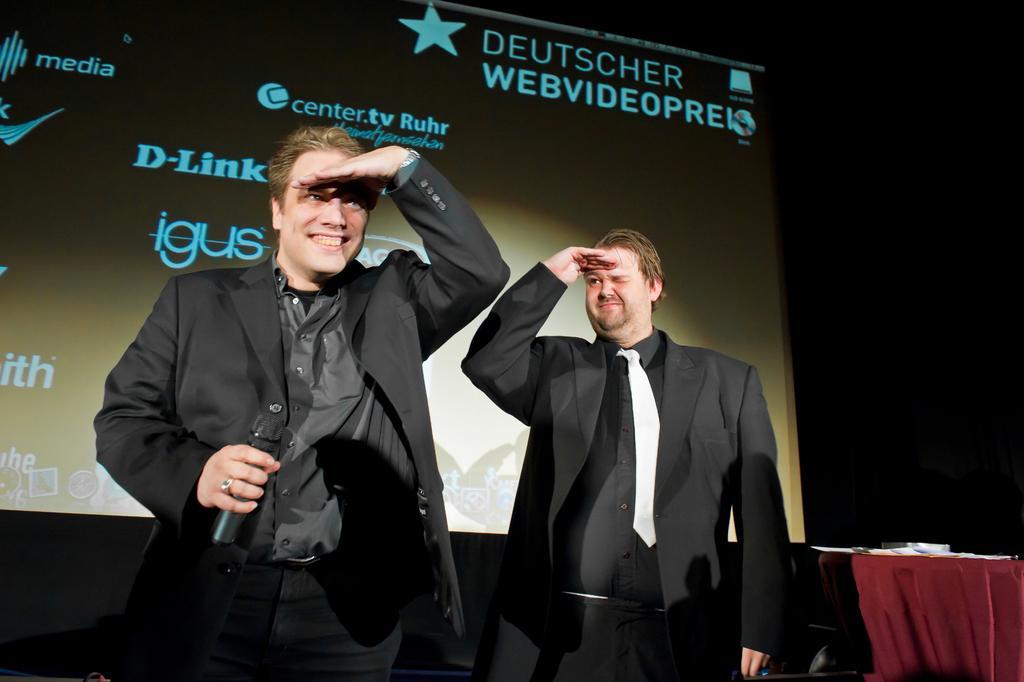Please provide a concise description of this image. In this picture we can see two men wearing black suit and standing on the stage, smiling and giving a pose to the camera. Behind there is a big projector screen and dark background. 